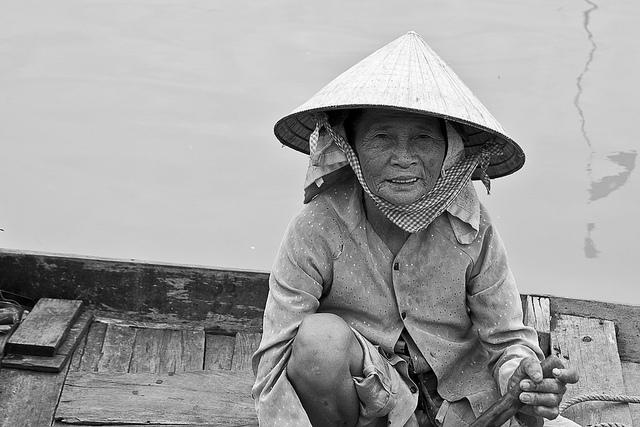What color is her helmet?
Concise answer only. White. What country was this taken in?
Quick response, please. China. What is the girls hat made of?
Keep it brief. Straw. Is there a dog in the photo?
Write a very short answer. No. Is the lady happy?
Write a very short answer. Yes. How many boys are shown?
Write a very short answer. 0. Is this a teenager?
Give a very brief answer. No. What is the hat called this person is wearing?
Quick response, please. Hat. What is the woman wearing on her head?
Quick response, please. Hat. What color hat is this woman wearing?
Short answer required. White. 